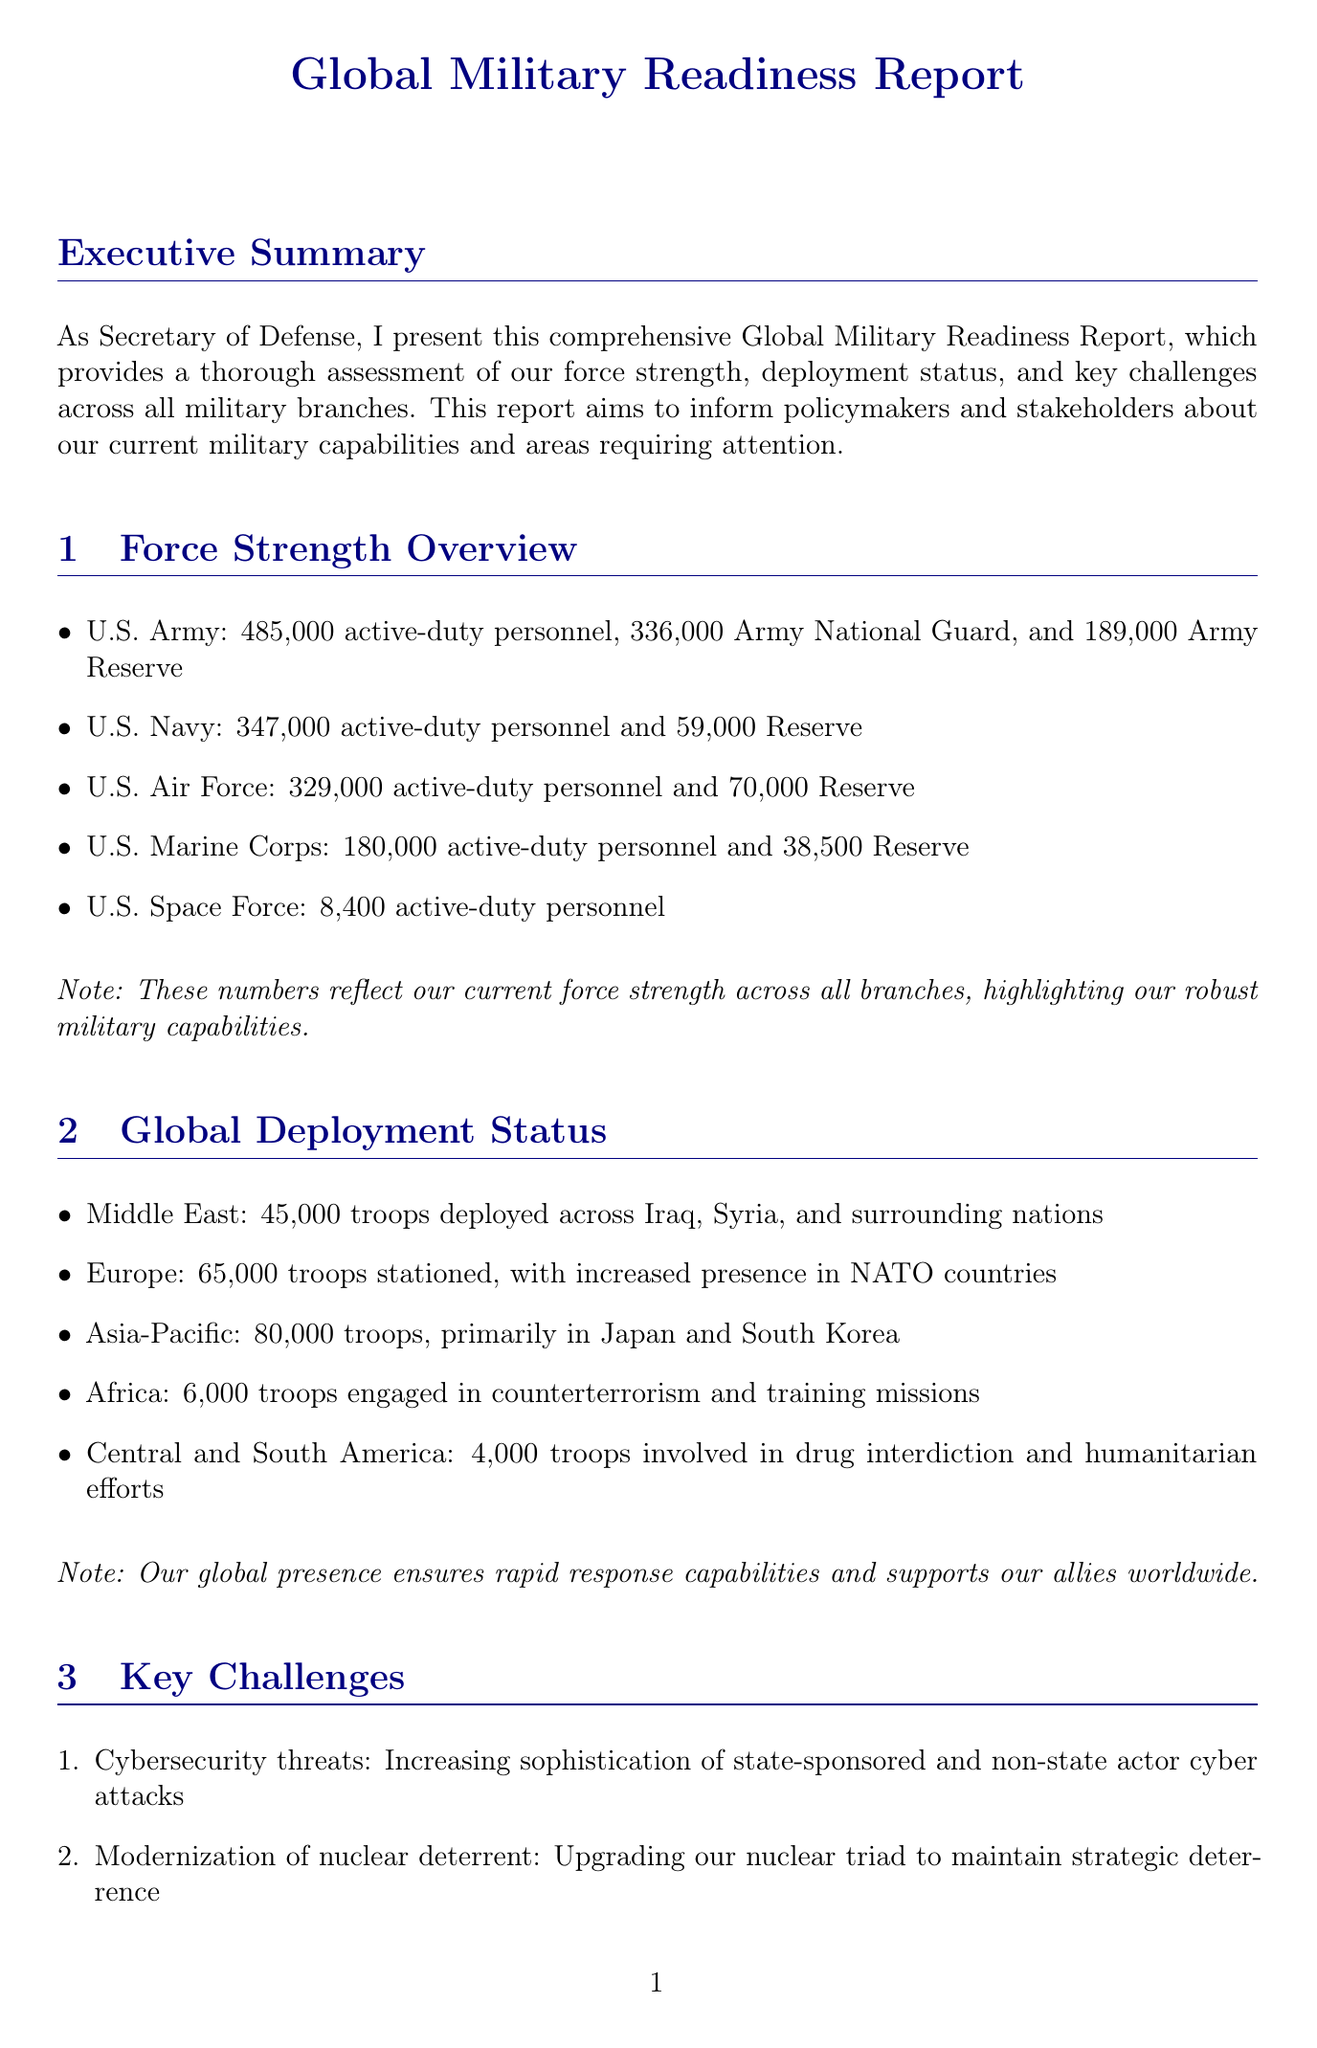what is the total active-duty personnel in the U.S. Army? The total active-duty personnel in the U.S. Army is specified in the force strength overview section, which states 485,000 personnel.
Answer: 485,000 how many troops are stationed in Europe? The global deployment status section mentions that there are 65,000 troops stationed in Europe.
Answer: 65,000 what is the budget request for nuclear modernization? The budget considerations section outlines that the request for nuclear modernization is $30.6 billion.
Answer: $30.6 billion which initiative is related to command and control? Readiness improvement initiatives mention the Joint All-Domain Command and Control (JADC2) implementation as a key initiative.
Answer: Joint All-Domain Command and Control (JADC2) what are the key challenges mentioned in the report? The document lists several key challenges, including cybersecurity threats, modernization of nuclear deterrent, space domain competition, near-peer competition, and climate change impacts.
Answer: Cybersecurity threats, modernization of nuclear deterrent, space domain competition, near-peer competition, climate change impacts what is the active-duty personnel count in the U.S. Space Force? The force strength overview specifies that there are 8,400 active-duty personnel in the U.S. Space Force.
Answer: 8,400 what percentage raise is proposed for military personnel? The budget considerations section indicates a proposed pay raise of 4.6% for military personnel.
Answer: 4.6% what global region has the highest troop deployment? The global deployment status section indicates that the Asia-Pacific region has the highest troop deployment with 80,000 troops.
Answer: Asia-Pacific how many troops are engaged in counterterrorism in Africa? The global deployment status reports that there are 6,000 troops engaged in counterterrorism and training missions in Africa.
Answer: 6,000 